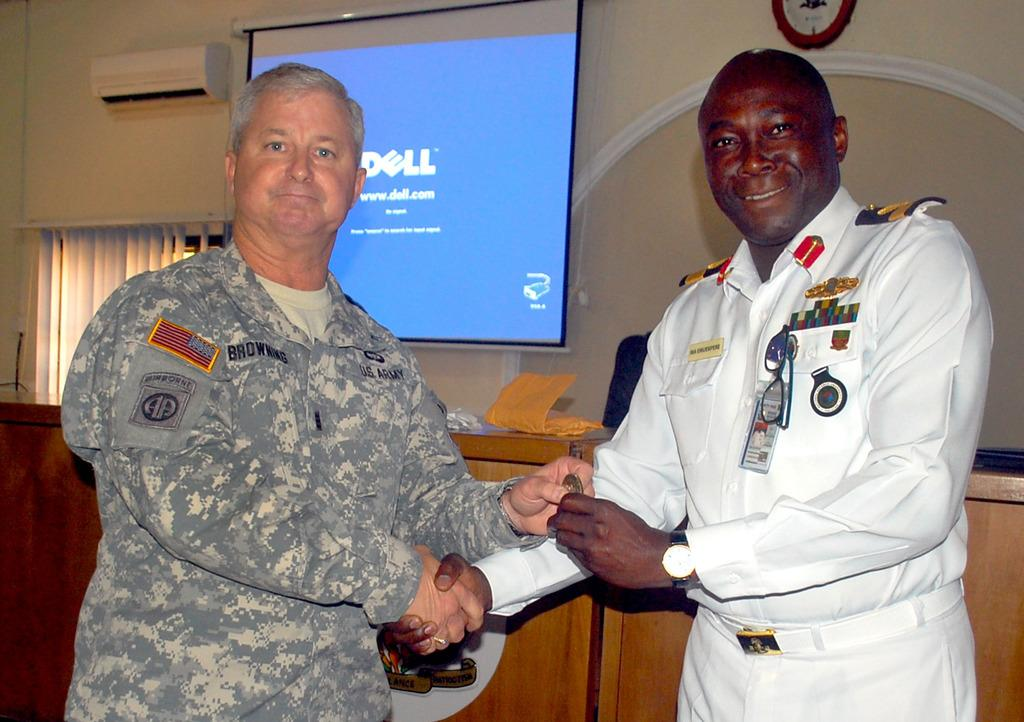Provide a one-sentence caption for the provided image. The presentation was made by Browning of the U.S. Army. 